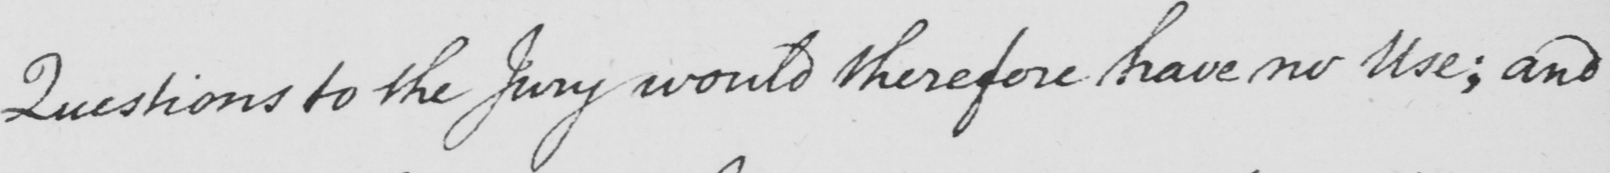What is written in this line of handwriting? Questions to the Jury would therefore have no Use; and 